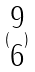<formula> <loc_0><loc_0><loc_500><loc_500>( \begin{matrix} 9 \\ 6 \end{matrix} )</formula> 